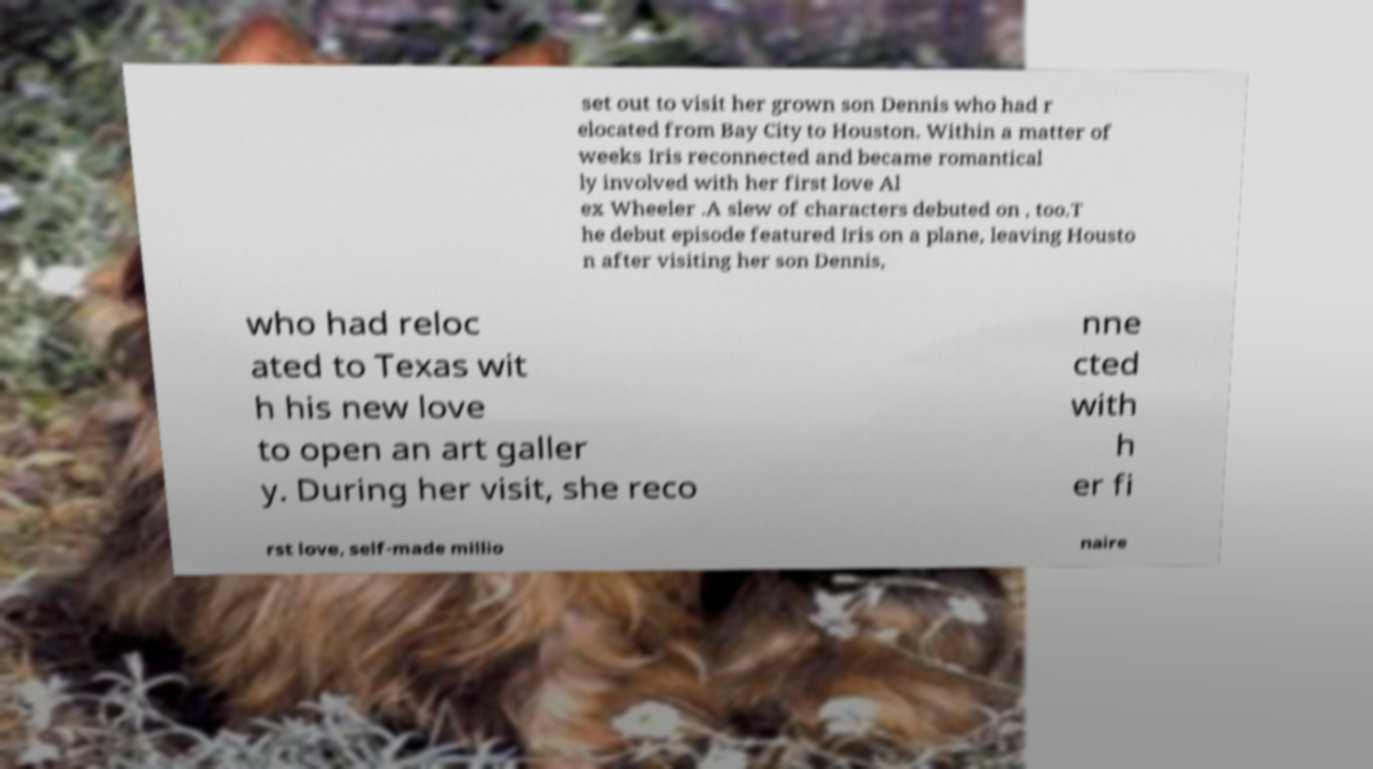Can you accurately transcribe the text from the provided image for me? set out to visit her grown son Dennis who had r elocated from Bay City to Houston. Within a matter of weeks Iris reconnected and became romantical ly involved with her first love Al ex Wheeler .A slew of characters debuted on , too.T he debut episode featured Iris on a plane, leaving Housto n after visiting her son Dennis, who had reloc ated to Texas wit h his new love to open an art galler y. During her visit, she reco nne cted with h er fi rst love, self-made millio naire 